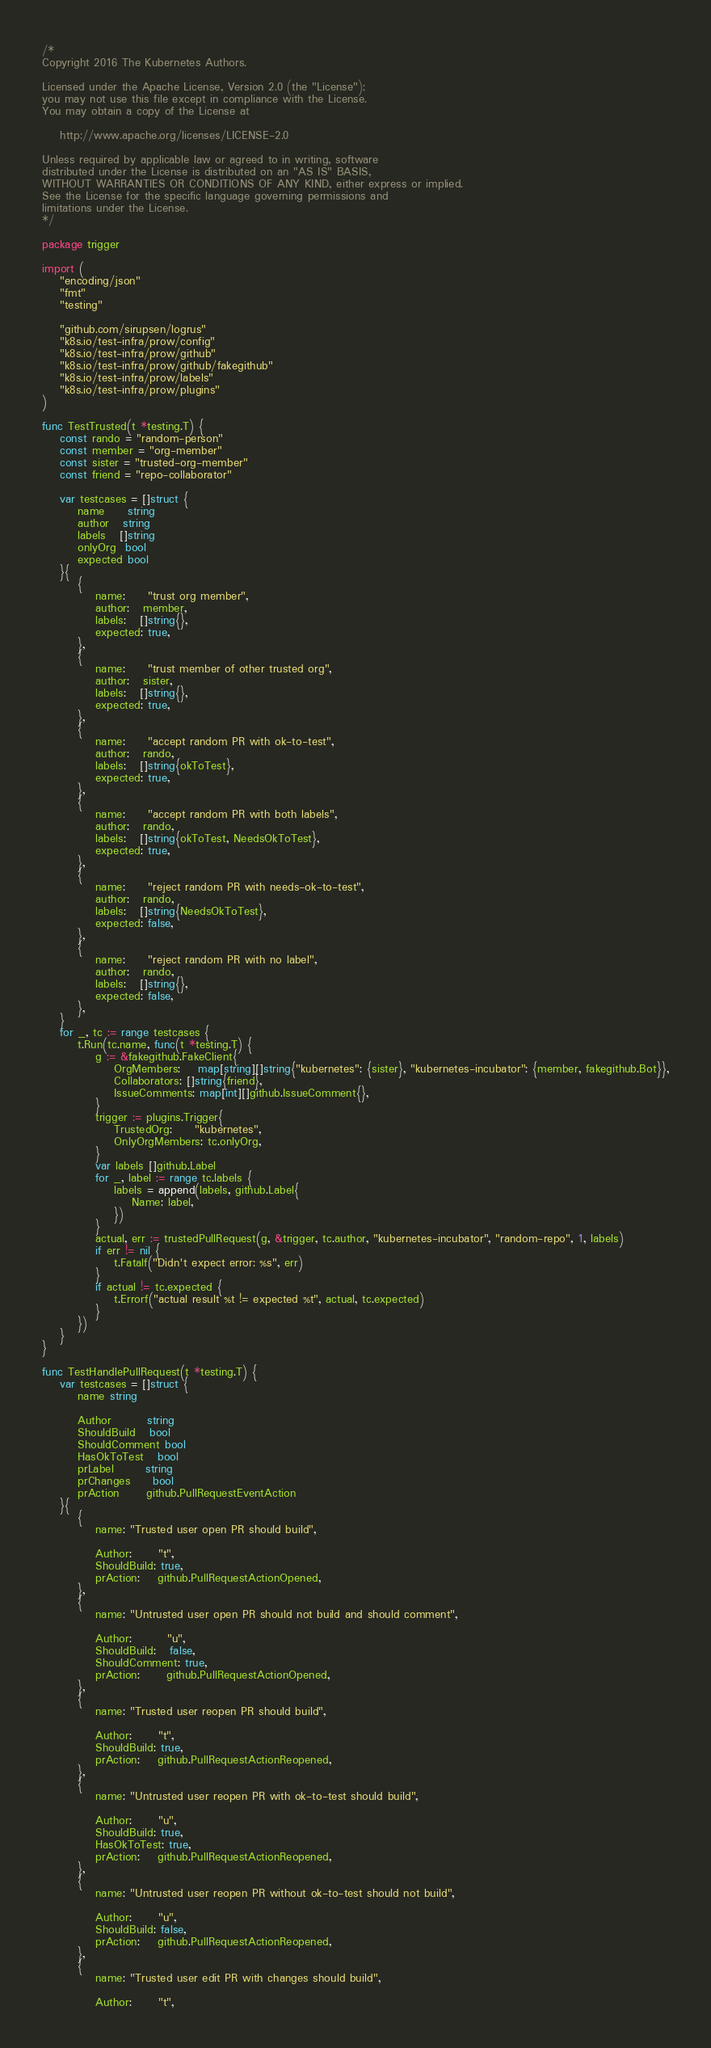<code> <loc_0><loc_0><loc_500><loc_500><_Go_>/*
Copyright 2016 The Kubernetes Authors.

Licensed under the Apache License, Version 2.0 (the "License");
you may not use this file except in compliance with the License.
You may obtain a copy of the License at

    http://www.apache.org/licenses/LICENSE-2.0

Unless required by applicable law or agreed to in writing, software
distributed under the License is distributed on an "AS IS" BASIS,
WITHOUT WARRANTIES OR CONDITIONS OF ANY KIND, either express or implied.
See the License for the specific language governing permissions and
limitations under the License.
*/

package trigger

import (
	"encoding/json"
	"fmt"
	"testing"

	"github.com/sirupsen/logrus"
	"k8s.io/test-infra/prow/config"
	"k8s.io/test-infra/prow/github"
	"k8s.io/test-infra/prow/github/fakegithub"
	"k8s.io/test-infra/prow/labels"
	"k8s.io/test-infra/prow/plugins"
)

func TestTrusted(t *testing.T) {
	const rando = "random-person"
	const member = "org-member"
	const sister = "trusted-org-member"
	const friend = "repo-collaborator"

	var testcases = []struct {
		name     string
		author   string
		labels   []string
		onlyOrg  bool
		expected bool
	}{
		{
			name:     "trust org member",
			author:   member,
			labels:   []string{},
			expected: true,
		},
		{
			name:     "trust member of other trusted org",
			author:   sister,
			labels:   []string{},
			expected: true,
		},
		{
			name:     "accept random PR with ok-to-test",
			author:   rando,
			labels:   []string{okToTest},
			expected: true,
		},
		{
			name:     "accept random PR with both labels",
			author:   rando,
			labels:   []string{okToTest, NeedsOkToTest},
			expected: true,
		},
		{
			name:     "reject random PR with needs-ok-to-test",
			author:   rando,
			labels:   []string{NeedsOkToTest},
			expected: false,
		},
		{
			name:     "reject random PR with no label",
			author:   rando,
			labels:   []string{},
			expected: false,
		},
	}
	for _, tc := range testcases {
		t.Run(tc.name, func(t *testing.T) {
			g := &fakegithub.FakeClient{
				OrgMembers:    map[string][]string{"kubernetes": {sister}, "kubernetes-incubator": {member, fakegithub.Bot}},
				Collaborators: []string{friend},
				IssueComments: map[int][]github.IssueComment{},
			}
			trigger := plugins.Trigger{
				TrustedOrg:     "kubernetes",
				OnlyOrgMembers: tc.onlyOrg,
			}
			var labels []github.Label
			for _, label := range tc.labels {
				labels = append(labels, github.Label{
					Name: label,
				})
			}
			actual, err := trustedPullRequest(g, &trigger, tc.author, "kubernetes-incubator", "random-repo", 1, labels)
			if err != nil {
				t.Fatalf("Didn't expect error: %s", err)
			}
			if actual != tc.expected {
				t.Errorf("actual result %t != expected %t", actual, tc.expected)
			}
		})
	}
}

func TestHandlePullRequest(t *testing.T) {
	var testcases = []struct {
		name string

		Author        string
		ShouldBuild   bool
		ShouldComment bool
		HasOkToTest   bool
		prLabel       string
		prChanges     bool
		prAction      github.PullRequestEventAction
	}{
		{
			name: "Trusted user open PR should build",

			Author:      "t",
			ShouldBuild: true,
			prAction:    github.PullRequestActionOpened,
		},
		{
			name: "Untrusted user open PR should not build and should comment",

			Author:        "u",
			ShouldBuild:   false,
			ShouldComment: true,
			prAction:      github.PullRequestActionOpened,
		},
		{
			name: "Trusted user reopen PR should build",

			Author:      "t",
			ShouldBuild: true,
			prAction:    github.PullRequestActionReopened,
		},
		{
			name: "Untrusted user reopen PR with ok-to-test should build",

			Author:      "u",
			ShouldBuild: true,
			HasOkToTest: true,
			prAction:    github.PullRequestActionReopened,
		},
		{
			name: "Untrusted user reopen PR without ok-to-test should not build",

			Author:      "u",
			ShouldBuild: false,
			prAction:    github.PullRequestActionReopened,
		},
		{
			name: "Trusted user edit PR with changes should build",

			Author:      "t",</code> 